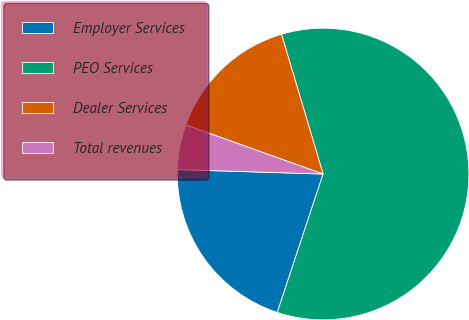Convert chart. <chart><loc_0><loc_0><loc_500><loc_500><pie_chart><fcel>Employer Services<fcel>PEO Services<fcel>Dealer Services<fcel>Total revenues<nl><fcel>20.4%<fcel>59.7%<fcel>14.93%<fcel>4.98%<nl></chart> 